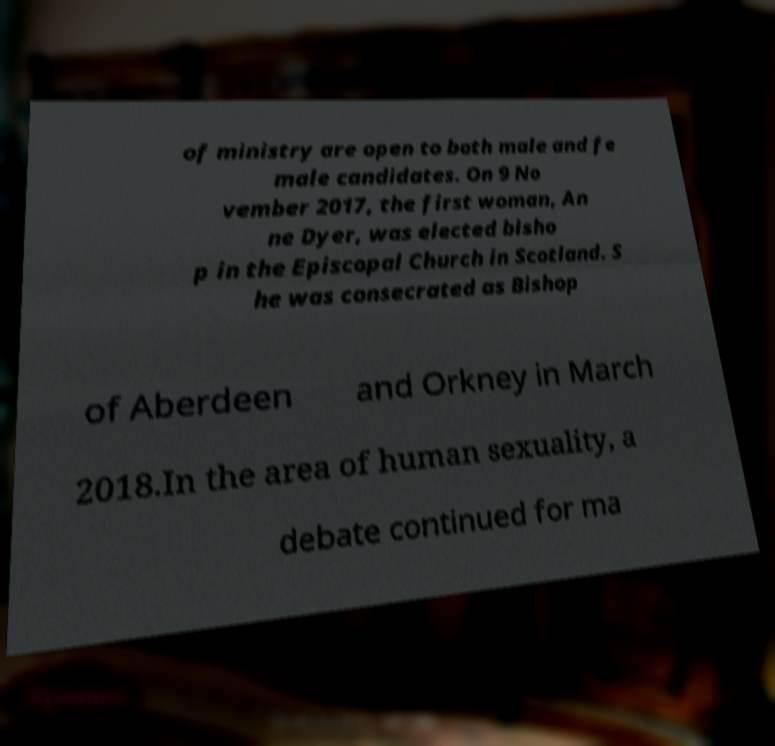Can you read and provide the text displayed in the image?This photo seems to have some interesting text. Can you extract and type it out for me? of ministry are open to both male and fe male candidates. On 9 No vember 2017, the first woman, An ne Dyer, was elected bisho p in the Episcopal Church in Scotland. S he was consecrated as Bishop of Aberdeen and Orkney in March 2018.In the area of human sexuality, a debate continued for ma 